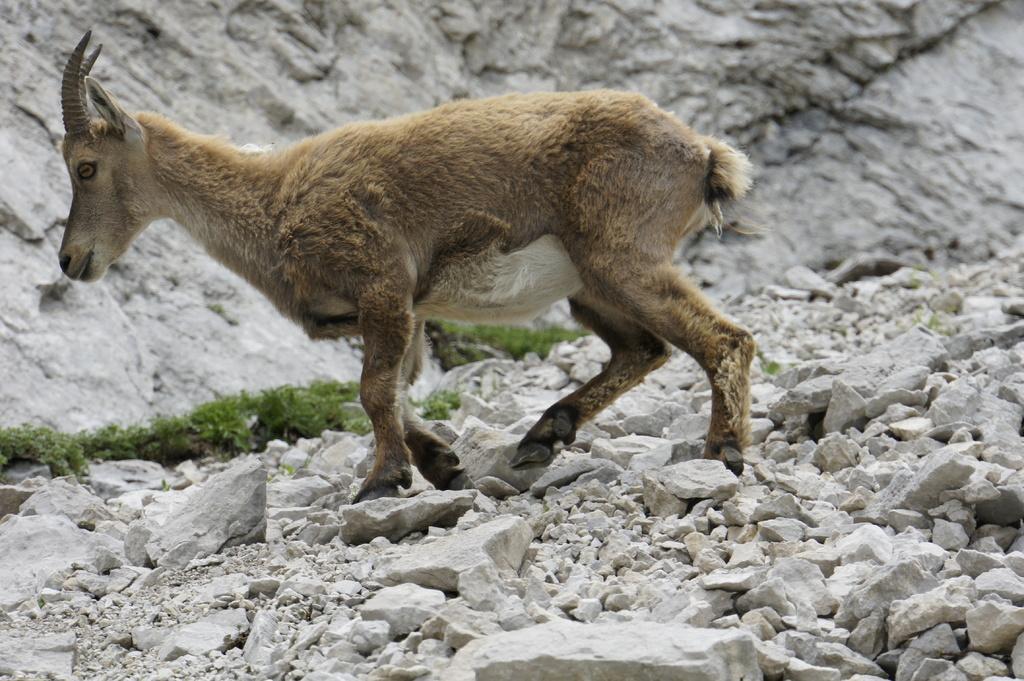Describe this image in one or two sentences. In the picture we can see an animal walking on the rock surface, just beside it, we can see some grass and rock wall. 